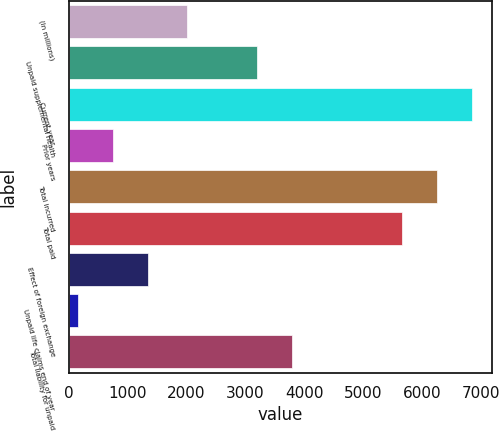Convert chart. <chart><loc_0><loc_0><loc_500><loc_500><bar_chart><fcel>(In millions)<fcel>Unpaid supplemental health<fcel>Current year<fcel>Prior years<fcel>Total incurred<fcel>Total paid<fcel>Effect of foreign exchange<fcel>Unpaid life claims end of year<fcel>Total liability for unpaid<nl><fcel>2008<fcel>3201.6<fcel>6846.6<fcel>755.8<fcel>6249.8<fcel>5653<fcel>1352.6<fcel>159<fcel>3798.4<nl></chart> 